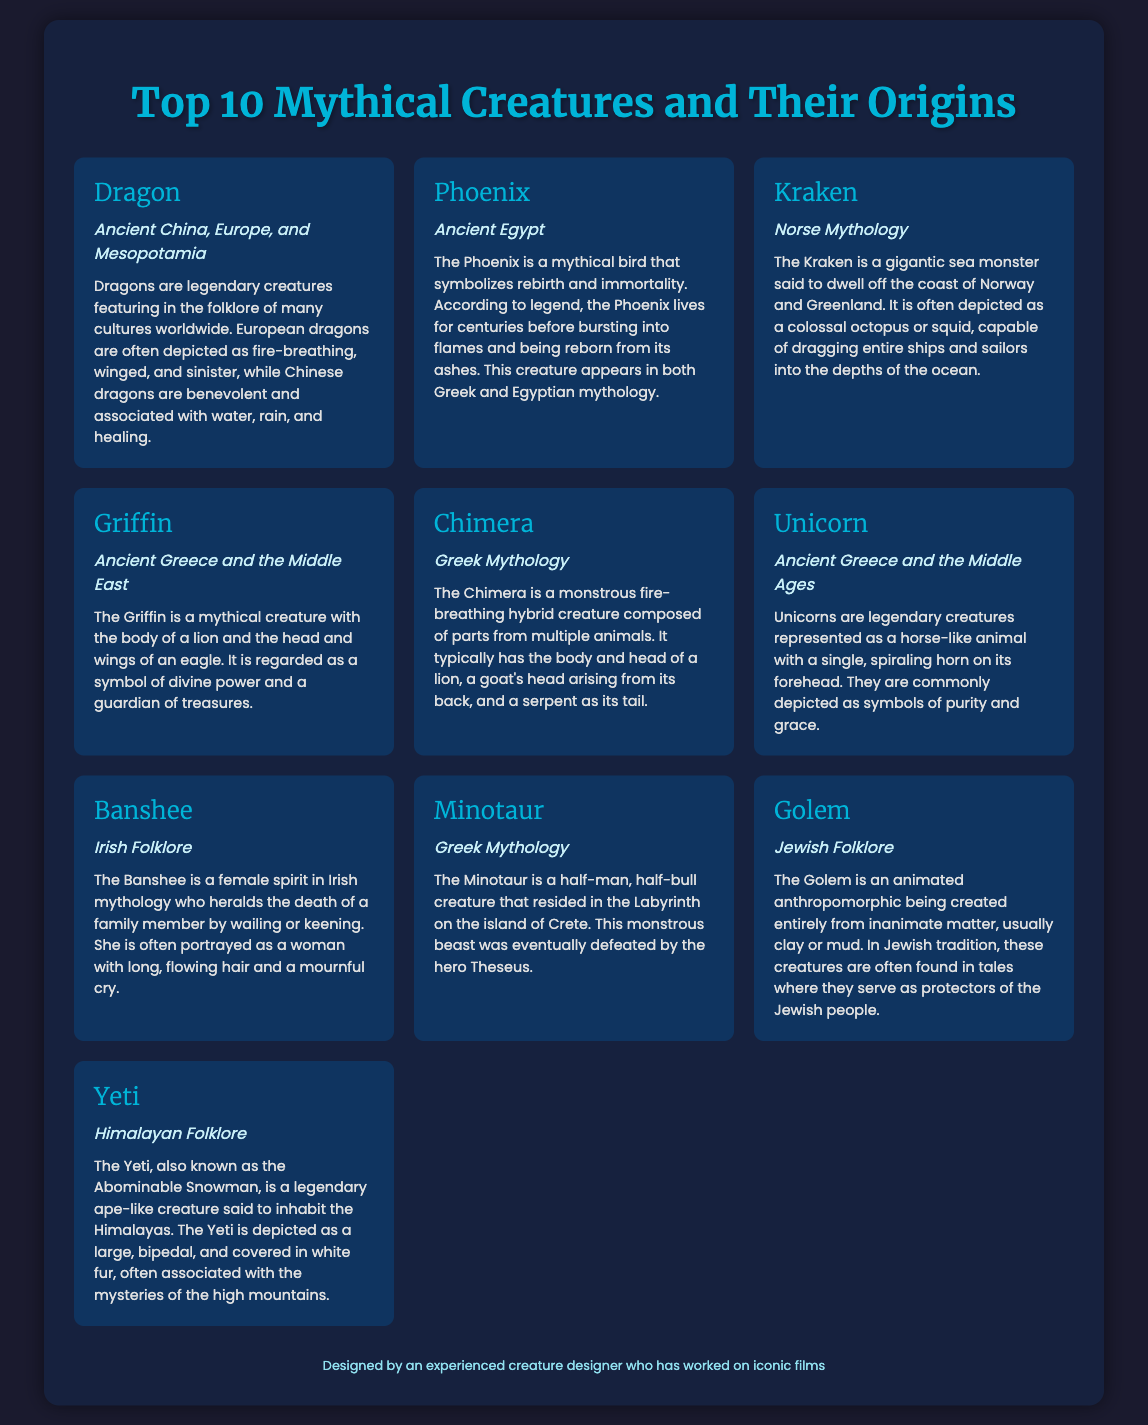What is the origin of the Dragon? The origin of the Dragon is listed as Ancient China, Europe, and Mesopotamia in the document.
Answer: Ancient China, Europe, and Mesopotamia Which mythical creature symbolizes rebirth? The mythical creature that symbolizes rebirth is the Phoenix, as described in the document.
Answer: Phoenix How many heads does the Chimera have? The Chimera is described as having the body and head of a lion, a goat's head arising from its back, and a serpent as its tail, implying it has at least two heads.
Answer: At least two heads What type of creature is a Banshee? The Banshee is described as a female spirit in Irish mythology in the document.
Answer: Female spirit Which creature is depicted as a half-man, half-bull? The creature depicted as a half-man, half-bull is the Minotaur, according to the description in the document.
Answer: Minotaur From what folklore does the Golem originate? The Golem originates from Jewish Folklore, as stated in the document.
Answer: Jewish Folklore What does the Griffin symbolize? The Griffin is regarded as a symbol of divine power, as mentioned in the document.
Answer: Divine power Which mythical creature is associated with the Himalayas? The mythical creature associated with the Himalayas is the Yeti, according to the document.
Answer: Yeti 